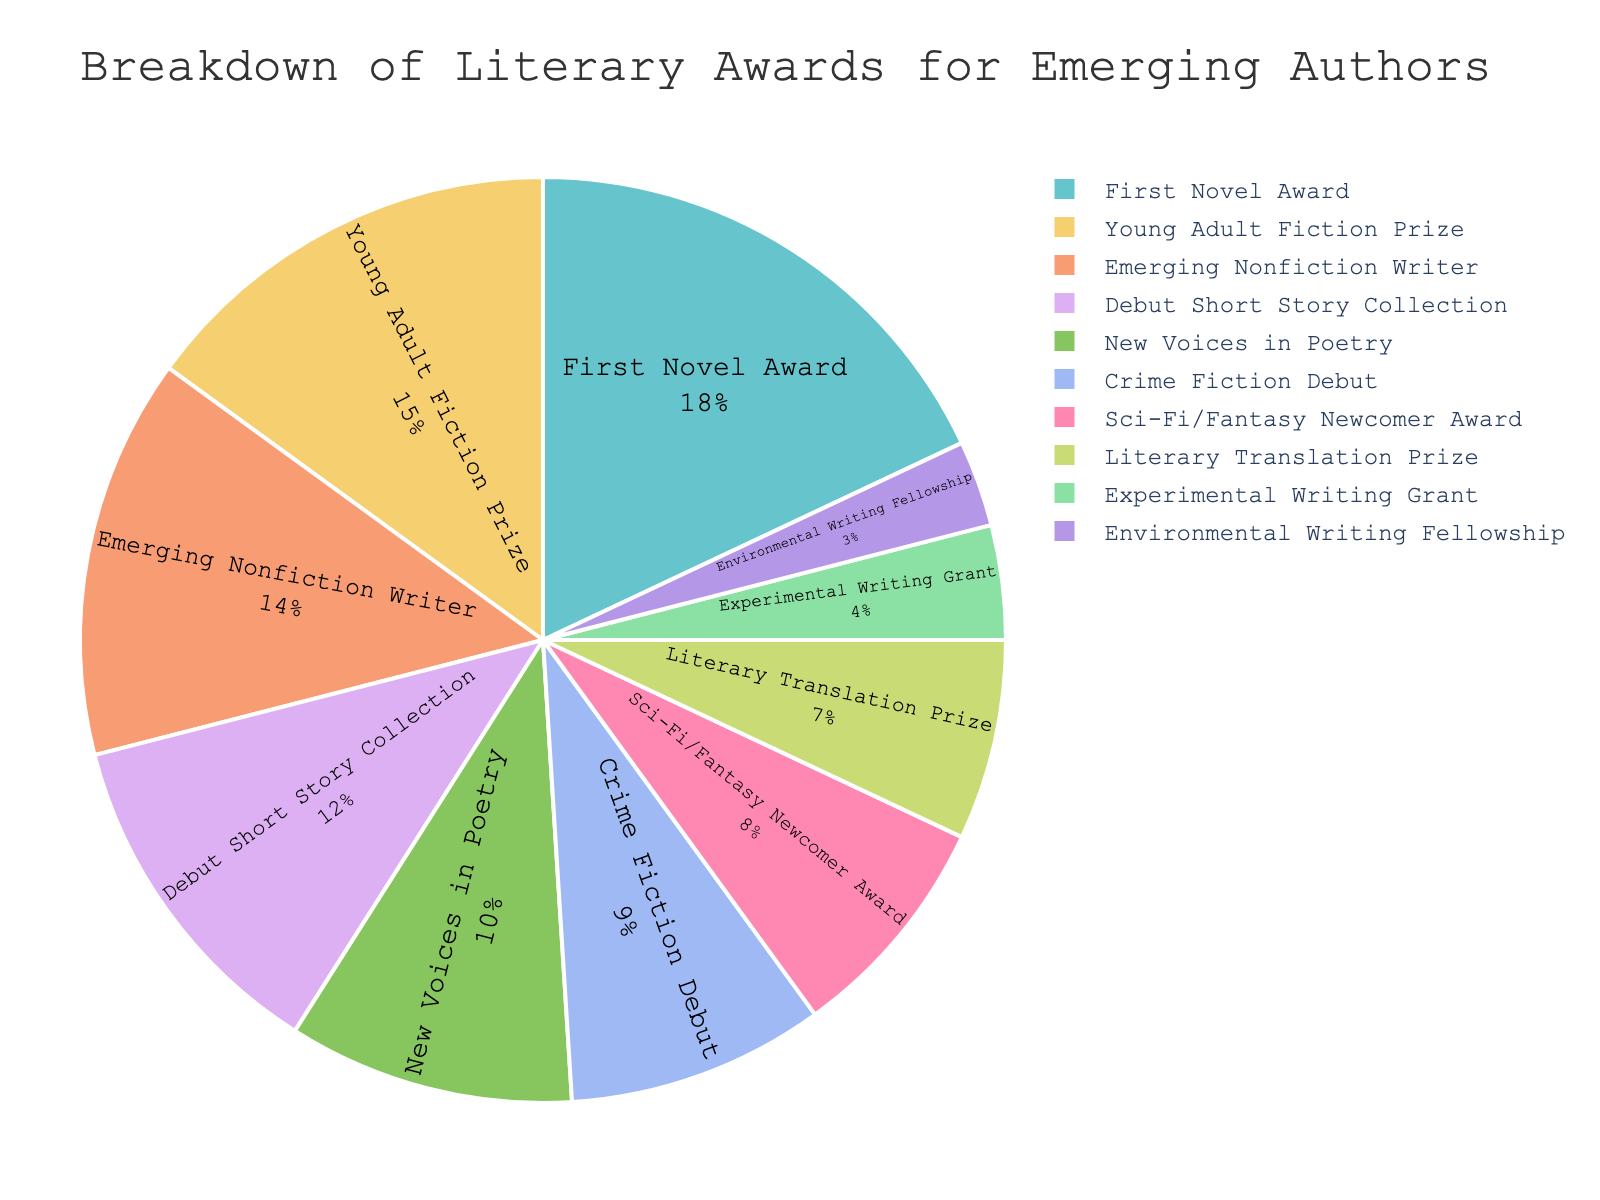Which category has the highest percentage of literary awards? The pie chart shows the breakdown of percentages for each category, and the highest percentage slice is "First Novel Award" at 18%.
Answer: First Novel Award What is the total percentage of awards given for Young Adult Fiction Prize and Emerging Nonfiction Writer? To find the total, add the percentages of Young Adult Fiction Prize (15%) and Emerging Nonfiction Writer (14%). 15% + 14% = 29%.
Answer: 29% Which category has a slightly higher percentage of awards, Crime Fiction Debut or Sci-Fi/Fantasy Newcomer Award? The Crime Fiction Debut has a percentage of 9%, and Sci-Fi/Fantasy Newcomer Award has a percentage of 8%. 9% is slightly higher than 8%.
Answer: Crime Fiction Debut What is the combined percentage of awards for Debut Short Story Collection, New Voices in Poetry, and Crime Fiction Debut? Add the percentages for Debut Short Story Collection (12%), New Voices in Poetry (10%), and Crime Fiction Debut (9%). 12% + 10% + 9% = 31%.
Answer: 31% Which category has the smallest percentage of awards, and what is that percentage? The smallest slice in the pie chart is the "Environmental Writing Fellowship" with a percentage of 3%.
Answer: Environmental Writing Fellowship, 3% How does the percentage of the Literary Translation Prize compare to that of the Experimental Writing Grant? The Literary Translation Prize has a percentage of 7%, while the Experimental Writing Grant has 4%. 7% is greater than 4%.
Answer: Literary Translation Prize What is the difference in percentage between the First Novel Award and the Experimental Writing Grant? Subtract the percentage of the Experimental Writing Grant (4%) from the First Novel Award (18%). 18% - 4% = 14%.
Answer: 14% What is the average percentage of awards across all categories? Sum all percentages: 18% + 15% + 12% + 10% + 14% + 8% + 9% + 7% + 4% + 3% = 100%. Then divide by the number of categories, which is 10. 100% / 10 = 10%.
Answer: 10% Which category accounts for the third-largest percentage of awards? The three largest percentages are First Novel Award (18%), Young Adult Fiction Prize (15%), and Emerging Nonfiction Writer (14%). Emerging Nonfiction Writer is the third-largest.
Answer: Emerging Nonfiction Writer 